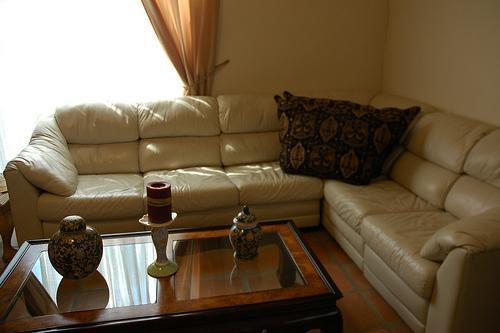How many vases are there?
Give a very brief answer. 2. 